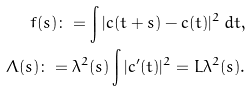<formula> <loc_0><loc_0><loc_500><loc_500>f ( s ) \colon = \int | c ( t + s ) - c ( t ) | ^ { 2 } \, d t , \\ \Lambda ( s ) \colon = \lambda ^ { 2 } ( s ) \int | c ^ { \prime } ( t ) | ^ { 2 } = L \lambda ^ { 2 } ( s ) .</formula> 